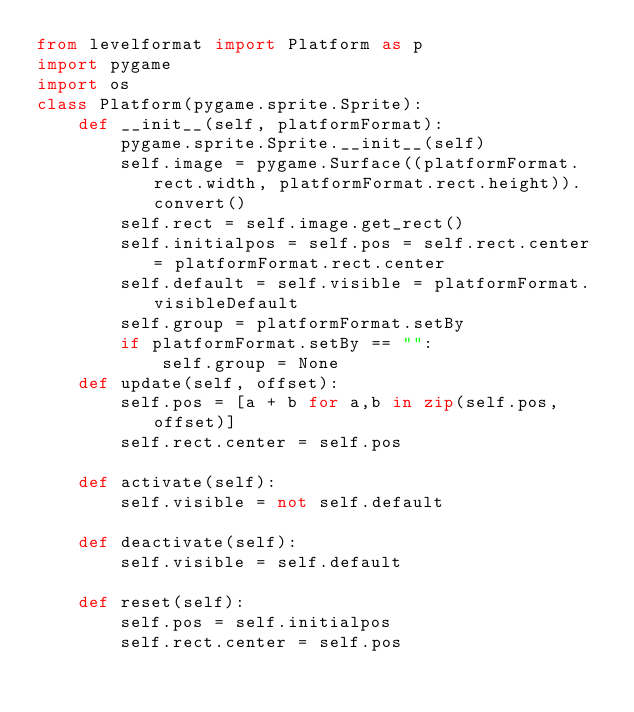<code> <loc_0><loc_0><loc_500><loc_500><_Python_>from levelformat import Platform as p
import pygame
import os
class Platform(pygame.sprite.Sprite):
    def __init__(self, platformFormat):
        pygame.sprite.Sprite.__init__(self)
        self.image = pygame.Surface((platformFormat.rect.width, platformFormat.rect.height)).convert()
        self.rect = self.image.get_rect()
        self.initialpos = self.pos = self.rect.center = platformFormat.rect.center
        self.default = self.visible = platformFormat.visibleDefault
        self.group = platformFormat.setBy
        if platformFormat.setBy == "":
            self.group = None
    def update(self, offset):
        self.pos = [a + b for a,b in zip(self.pos, offset)]
        self.rect.center = self.pos
        
    def activate(self):
        self.visible = not self.default

    def deactivate(self):
        self.visible = self.default

    def reset(self):
        self.pos = self.initialpos
        self.rect.center = self.pos
</code> 